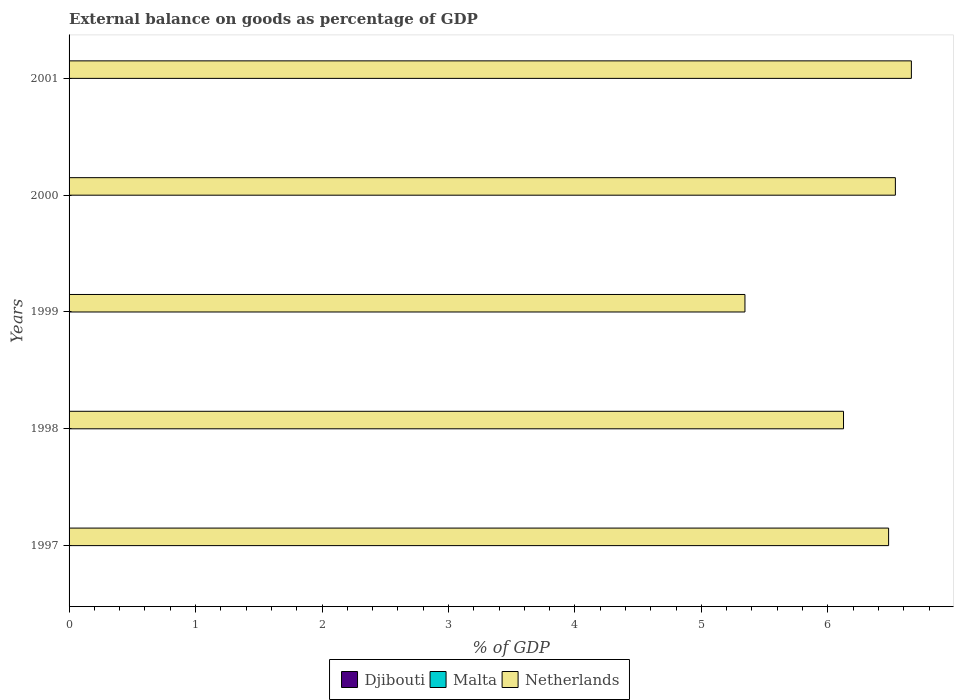How many different coloured bars are there?
Your answer should be very brief. 1. What is the label of the 1st group of bars from the top?
Your answer should be very brief. 2001. In how many cases, is the number of bars for a given year not equal to the number of legend labels?
Your answer should be compact. 5. What is the external balance on goods as percentage of GDP in Netherlands in 2000?
Your answer should be compact. 6.53. Across all years, what is the maximum external balance on goods as percentage of GDP in Netherlands?
Your answer should be compact. 6.66. Across all years, what is the minimum external balance on goods as percentage of GDP in Malta?
Provide a succinct answer. 0. What is the difference between the external balance on goods as percentage of GDP in Netherlands in 1997 and that in 2001?
Ensure brevity in your answer.  -0.18. What is the average external balance on goods as percentage of GDP in Djibouti per year?
Your answer should be compact. 0. What is the ratio of the external balance on goods as percentage of GDP in Netherlands in 1997 to that in 2000?
Make the answer very short. 0.99. Is the sum of the external balance on goods as percentage of GDP in Netherlands in 1999 and 2001 greater than the maximum external balance on goods as percentage of GDP in Malta across all years?
Offer a very short reply. Yes. Are all the bars in the graph horizontal?
Your answer should be very brief. Yes. What is the difference between two consecutive major ticks on the X-axis?
Keep it short and to the point. 1. Are the values on the major ticks of X-axis written in scientific E-notation?
Your answer should be compact. No. Does the graph contain any zero values?
Provide a succinct answer. Yes. Does the graph contain grids?
Provide a succinct answer. No. How many legend labels are there?
Provide a short and direct response. 3. How are the legend labels stacked?
Your response must be concise. Horizontal. What is the title of the graph?
Provide a short and direct response. External balance on goods as percentage of GDP. Does "Sweden" appear as one of the legend labels in the graph?
Keep it short and to the point. No. What is the label or title of the X-axis?
Make the answer very short. % of GDP. What is the label or title of the Y-axis?
Offer a very short reply. Years. What is the % of GDP in Djibouti in 1997?
Keep it short and to the point. 0. What is the % of GDP in Netherlands in 1997?
Your answer should be compact. 6.48. What is the % of GDP in Djibouti in 1998?
Keep it short and to the point. 0. What is the % of GDP in Malta in 1998?
Keep it short and to the point. 0. What is the % of GDP in Netherlands in 1998?
Your answer should be compact. 6.12. What is the % of GDP in Netherlands in 1999?
Keep it short and to the point. 5.34. What is the % of GDP in Djibouti in 2000?
Give a very brief answer. 0. What is the % of GDP of Netherlands in 2000?
Provide a short and direct response. 6.53. What is the % of GDP of Netherlands in 2001?
Offer a terse response. 6.66. Across all years, what is the maximum % of GDP of Netherlands?
Keep it short and to the point. 6.66. Across all years, what is the minimum % of GDP in Netherlands?
Offer a terse response. 5.34. What is the total % of GDP of Malta in the graph?
Keep it short and to the point. 0. What is the total % of GDP of Netherlands in the graph?
Give a very brief answer. 31.14. What is the difference between the % of GDP of Netherlands in 1997 and that in 1998?
Provide a succinct answer. 0.36. What is the difference between the % of GDP in Netherlands in 1997 and that in 1999?
Offer a terse response. 1.14. What is the difference between the % of GDP of Netherlands in 1997 and that in 2000?
Your answer should be very brief. -0.05. What is the difference between the % of GDP of Netherlands in 1997 and that in 2001?
Your response must be concise. -0.18. What is the difference between the % of GDP of Netherlands in 1998 and that in 1999?
Give a very brief answer. 0.78. What is the difference between the % of GDP of Netherlands in 1998 and that in 2000?
Ensure brevity in your answer.  -0.41. What is the difference between the % of GDP in Netherlands in 1998 and that in 2001?
Offer a very short reply. -0.54. What is the difference between the % of GDP in Netherlands in 1999 and that in 2000?
Your response must be concise. -1.19. What is the difference between the % of GDP of Netherlands in 1999 and that in 2001?
Your answer should be very brief. -1.32. What is the difference between the % of GDP of Netherlands in 2000 and that in 2001?
Your answer should be very brief. -0.13. What is the average % of GDP of Malta per year?
Make the answer very short. 0. What is the average % of GDP of Netherlands per year?
Make the answer very short. 6.23. What is the ratio of the % of GDP of Netherlands in 1997 to that in 1998?
Your response must be concise. 1.06. What is the ratio of the % of GDP in Netherlands in 1997 to that in 1999?
Provide a short and direct response. 1.21. What is the ratio of the % of GDP in Netherlands in 1998 to that in 1999?
Offer a terse response. 1.15. What is the ratio of the % of GDP in Netherlands in 1998 to that in 2000?
Provide a succinct answer. 0.94. What is the ratio of the % of GDP in Netherlands in 1998 to that in 2001?
Your answer should be very brief. 0.92. What is the ratio of the % of GDP of Netherlands in 1999 to that in 2000?
Make the answer very short. 0.82. What is the ratio of the % of GDP of Netherlands in 1999 to that in 2001?
Give a very brief answer. 0.8. What is the ratio of the % of GDP of Netherlands in 2000 to that in 2001?
Your answer should be compact. 0.98. What is the difference between the highest and the second highest % of GDP of Netherlands?
Give a very brief answer. 0.13. What is the difference between the highest and the lowest % of GDP in Netherlands?
Ensure brevity in your answer.  1.32. 